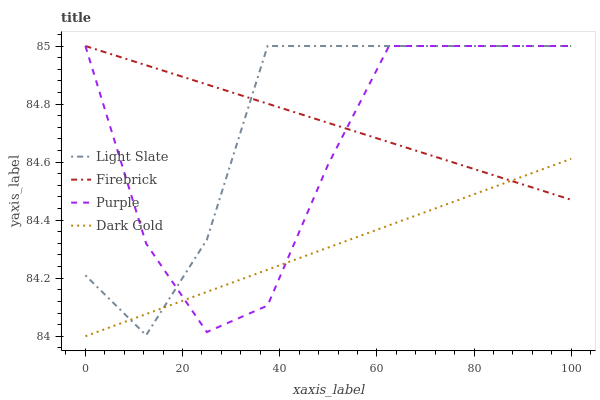Does Dark Gold have the minimum area under the curve?
Answer yes or no. Yes. Does Light Slate have the maximum area under the curve?
Answer yes or no. Yes. Does Purple have the minimum area under the curve?
Answer yes or no. No. Does Purple have the maximum area under the curve?
Answer yes or no. No. Is Firebrick the smoothest?
Answer yes or no. Yes. Is Purple the roughest?
Answer yes or no. Yes. Is Purple the smoothest?
Answer yes or no. No. Is Firebrick the roughest?
Answer yes or no. No. Does Dark Gold have the lowest value?
Answer yes or no. Yes. Does Purple have the lowest value?
Answer yes or no. No. Does Firebrick have the highest value?
Answer yes or no. Yes. Does Dark Gold have the highest value?
Answer yes or no. No. Does Light Slate intersect Firebrick?
Answer yes or no. Yes. Is Light Slate less than Firebrick?
Answer yes or no. No. Is Light Slate greater than Firebrick?
Answer yes or no. No. 